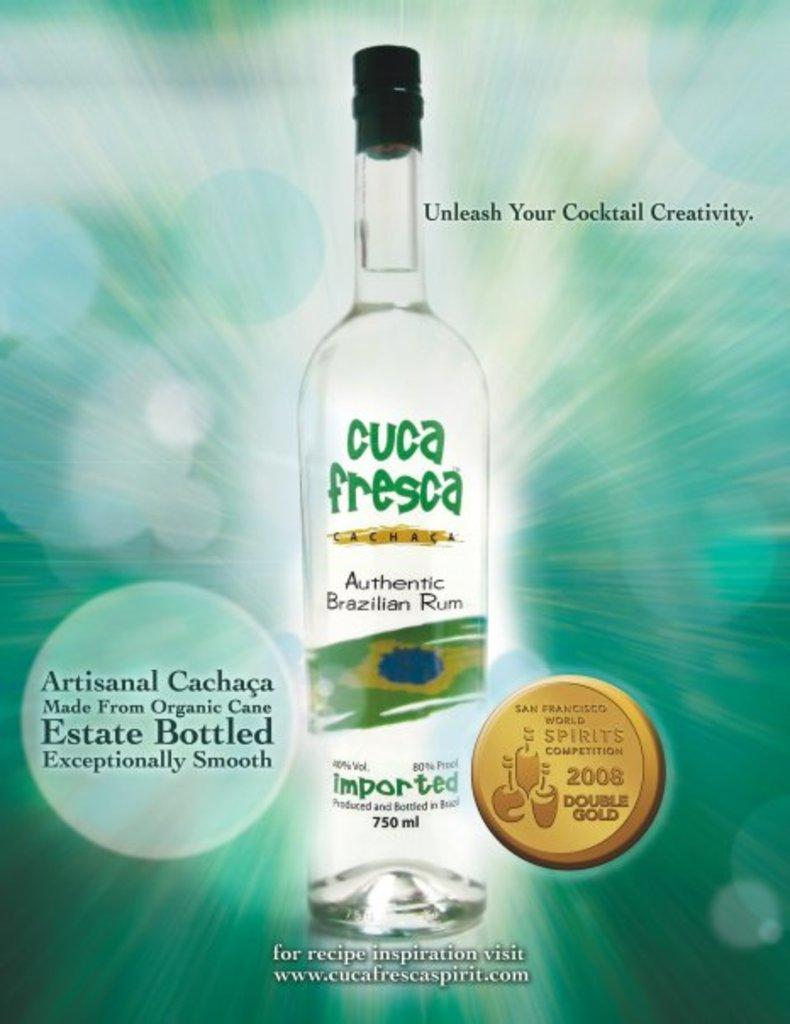<image>
Create a compact narrative representing the image presented. Ad for a bottle of Cuca Fresca saying "Unleash Your Cocktail Creativity". 